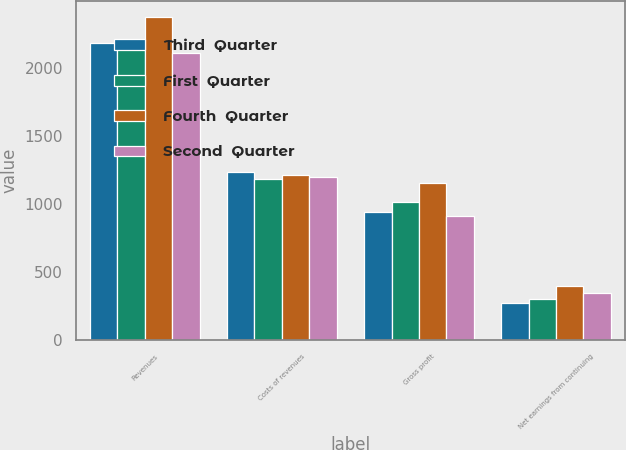Convert chart to OTSL. <chart><loc_0><loc_0><loc_500><loc_500><stacked_bar_chart><ecel><fcel>Revenues<fcel>Costs of revenues<fcel>Gross profit<fcel>Net earnings from continuing<nl><fcel>Third  Quarter<fcel>2181.5<fcel>1236.7<fcel>944.8<fcel>278<nl><fcel>First  Quarter<fcel>2203.3<fcel>1187.5<fcel>1015.8<fcel>300.4<nl><fcel>Fourth  Quarter<fcel>2374.7<fcel>1218.6<fcel>1156.1<fcel>402.5<nl><fcel>Second  Quarter<fcel>2107.7<fcel>1196.6<fcel>911.1<fcel>347.4<nl></chart> 